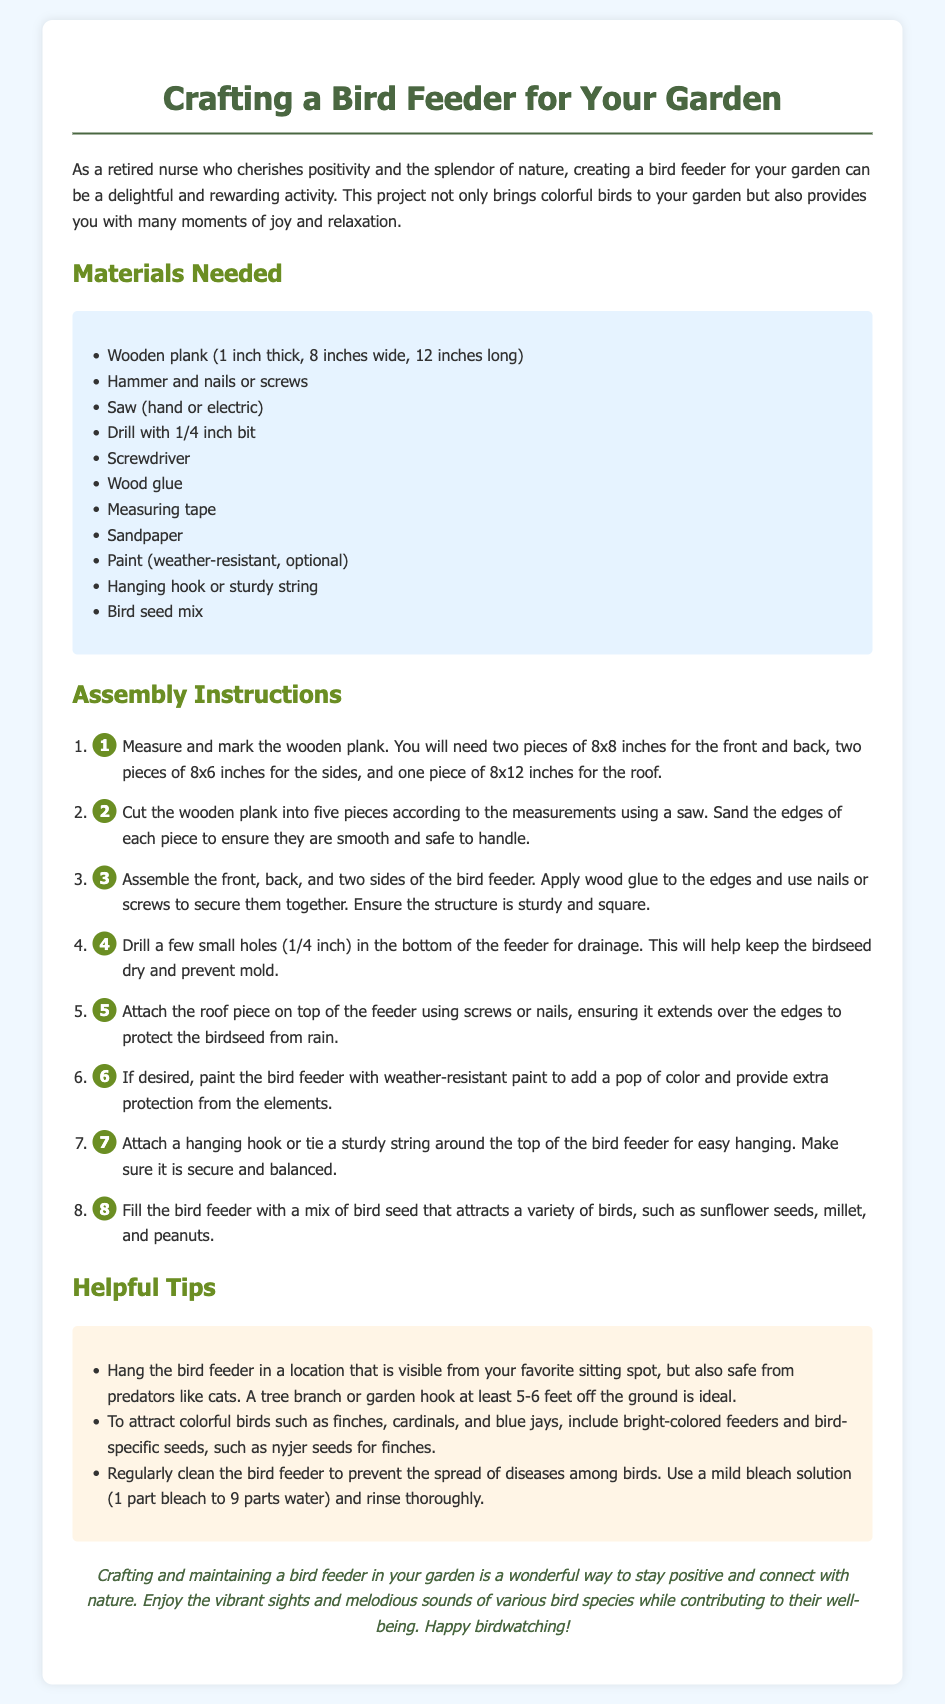What materials are needed to make the bird feeder? The materials list consists of ten items specifically mentioned in the document, which includes a wooden plank, hammer, nails or screws, and others.
Answer: Wooden plank, hammer, nails, screws, saw, drill, screwdriver, wood glue, measuring tape, sandpaper, paint, hanging hook, bird seed mix How many pieces are needed for the roof? The instructions state that one piece of 8x12 inches is required for the roof of the bird feeder.
Answer: One piece What size are the front and back pieces of the bird feeder? The document clearly specifies the size for the front and back pieces as being 8 by 8 inches each.
Answer: 8x8 inches What is the purpose of drilling holes in the bottom of the feeder? The document explains that drilling holes in the bottom allows for drainage, keeping the birdseed dry.
Answer: Drainage Where should the bird feeder be hung? The document recommends that the bird feeder is hung in a visible location from a sitting spot, safely off the ground.
Answer: At least 5-6 feet off the ground What type of paint should be used, if desired? The assembly instructions mention using weather-resistant paint to add color and protection.
Answer: Weather-resistant Why is it important to clean the bird feeder regularly? The document highlights the importance of cleaning to prevent the spread of diseases among birds.
Answer: Prevent diseases What types of birds can be attracted by using specific seeds? The document suggests that finches, cardinals, and blue jays can be attracted using bird-specific seeds.
Answer: Finches, cardinals, blue jays How does crafting a bird feeder contribute to personal well-being? The conclusion emphasizes the positivity and connection with nature that comes from crafting and maintaining a bird feeder.
Answer: Stay positive and connect with nature 